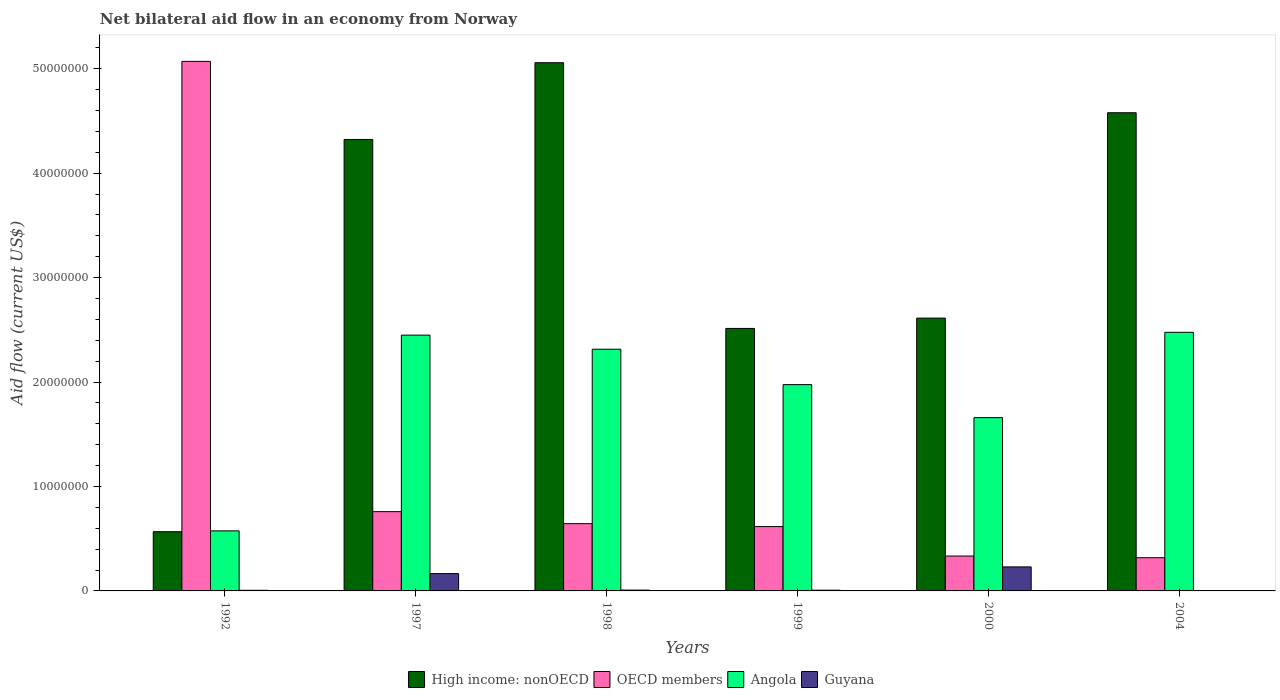Are the number of bars per tick equal to the number of legend labels?
Provide a succinct answer. Yes. Are the number of bars on each tick of the X-axis equal?
Offer a very short reply. Yes. How many bars are there on the 4th tick from the left?
Provide a short and direct response. 4. What is the label of the 5th group of bars from the left?
Offer a very short reply. 2000. In how many cases, is the number of bars for a given year not equal to the number of legend labels?
Your answer should be very brief. 0. What is the net bilateral aid flow in Angola in 1999?
Ensure brevity in your answer.  1.98e+07. Across all years, what is the maximum net bilateral aid flow in Guyana?
Ensure brevity in your answer.  2.30e+06. Across all years, what is the minimum net bilateral aid flow in Angola?
Provide a succinct answer. 5.75e+06. In which year was the net bilateral aid flow in OECD members maximum?
Your answer should be very brief. 1992. What is the total net bilateral aid flow in Angola in the graph?
Provide a short and direct response. 1.14e+08. What is the difference between the net bilateral aid flow in OECD members in 1992 and that in 2000?
Offer a very short reply. 4.74e+07. What is the difference between the net bilateral aid flow in Angola in 1998 and the net bilateral aid flow in Guyana in 1999?
Your response must be concise. 2.31e+07. What is the average net bilateral aid flow in OECD members per year?
Your answer should be very brief. 1.29e+07. In the year 1998, what is the difference between the net bilateral aid flow in Angola and net bilateral aid flow in Guyana?
Give a very brief answer. 2.31e+07. In how many years, is the net bilateral aid flow in Angola greater than 44000000 US$?
Your response must be concise. 0. What is the ratio of the net bilateral aid flow in Guyana in 1997 to that in 1999?
Offer a very short reply. 23.71. Is the difference between the net bilateral aid flow in Angola in 1992 and 2000 greater than the difference between the net bilateral aid flow in Guyana in 1992 and 2000?
Your answer should be compact. No. What is the difference between the highest and the second highest net bilateral aid flow in High income: nonOECD?
Provide a short and direct response. 4.79e+06. What is the difference between the highest and the lowest net bilateral aid flow in OECD members?
Give a very brief answer. 4.75e+07. Is the sum of the net bilateral aid flow in Angola in 1997 and 2000 greater than the maximum net bilateral aid flow in High income: nonOECD across all years?
Keep it short and to the point. No. Is it the case that in every year, the sum of the net bilateral aid flow in OECD members and net bilateral aid flow in Guyana is greater than the sum of net bilateral aid flow in High income: nonOECD and net bilateral aid flow in Angola?
Your answer should be compact. Yes. What does the 2nd bar from the right in 2004 represents?
Offer a terse response. Angola. Is it the case that in every year, the sum of the net bilateral aid flow in OECD members and net bilateral aid flow in Angola is greater than the net bilateral aid flow in High income: nonOECD?
Offer a terse response. No. Are all the bars in the graph horizontal?
Offer a terse response. No. How many years are there in the graph?
Keep it short and to the point. 6. What is the difference between two consecutive major ticks on the Y-axis?
Ensure brevity in your answer.  1.00e+07. Does the graph contain any zero values?
Keep it short and to the point. No. Does the graph contain grids?
Give a very brief answer. No. How many legend labels are there?
Provide a short and direct response. 4. What is the title of the graph?
Provide a short and direct response. Net bilateral aid flow in an economy from Norway. What is the label or title of the X-axis?
Give a very brief answer. Years. What is the label or title of the Y-axis?
Provide a succinct answer. Aid flow (current US$). What is the Aid flow (current US$) of High income: nonOECD in 1992?
Provide a short and direct response. 5.67e+06. What is the Aid flow (current US$) in OECD members in 1992?
Provide a short and direct response. 5.07e+07. What is the Aid flow (current US$) in Angola in 1992?
Ensure brevity in your answer.  5.75e+06. What is the Aid flow (current US$) in High income: nonOECD in 1997?
Your answer should be compact. 4.32e+07. What is the Aid flow (current US$) of OECD members in 1997?
Your answer should be compact. 7.59e+06. What is the Aid flow (current US$) in Angola in 1997?
Provide a succinct answer. 2.45e+07. What is the Aid flow (current US$) of Guyana in 1997?
Make the answer very short. 1.66e+06. What is the Aid flow (current US$) in High income: nonOECD in 1998?
Offer a very short reply. 5.06e+07. What is the Aid flow (current US$) in OECD members in 1998?
Keep it short and to the point. 6.44e+06. What is the Aid flow (current US$) of Angola in 1998?
Your answer should be compact. 2.31e+07. What is the Aid flow (current US$) in Guyana in 1998?
Your response must be concise. 8.00e+04. What is the Aid flow (current US$) in High income: nonOECD in 1999?
Your response must be concise. 2.51e+07. What is the Aid flow (current US$) in OECD members in 1999?
Offer a terse response. 6.16e+06. What is the Aid flow (current US$) in Angola in 1999?
Your answer should be compact. 1.98e+07. What is the Aid flow (current US$) in Guyana in 1999?
Make the answer very short. 7.00e+04. What is the Aid flow (current US$) of High income: nonOECD in 2000?
Your response must be concise. 2.61e+07. What is the Aid flow (current US$) of OECD members in 2000?
Ensure brevity in your answer.  3.34e+06. What is the Aid flow (current US$) in Angola in 2000?
Make the answer very short. 1.66e+07. What is the Aid flow (current US$) of Guyana in 2000?
Your answer should be very brief. 2.30e+06. What is the Aid flow (current US$) in High income: nonOECD in 2004?
Give a very brief answer. 4.58e+07. What is the Aid flow (current US$) of OECD members in 2004?
Make the answer very short. 3.18e+06. What is the Aid flow (current US$) in Angola in 2004?
Your answer should be compact. 2.48e+07. Across all years, what is the maximum Aid flow (current US$) of High income: nonOECD?
Give a very brief answer. 5.06e+07. Across all years, what is the maximum Aid flow (current US$) of OECD members?
Give a very brief answer. 5.07e+07. Across all years, what is the maximum Aid flow (current US$) in Angola?
Ensure brevity in your answer.  2.48e+07. Across all years, what is the maximum Aid flow (current US$) of Guyana?
Make the answer very short. 2.30e+06. Across all years, what is the minimum Aid flow (current US$) of High income: nonOECD?
Your response must be concise. 5.67e+06. Across all years, what is the minimum Aid flow (current US$) in OECD members?
Your response must be concise. 3.18e+06. Across all years, what is the minimum Aid flow (current US$) of Angola?
Give a very brief answer. 5.75e+06. Across all years, what is the minimum Aid flow (current US$) in Guyana?
Keep it short and to the point. 3.00e+04. What is the total Aid flow (current US$) in High income: nonOECD in the graph?
Your answer should be very brief. 1.96e+08. What is the total Aid flow (current US$) in OECD members in the graph?
Offer a very short reply. 7.74e+07. What is the total Aid flow (current US$) in Angola in the graph?
Offer a very short reply. 1.14e+08. What is the total Aid flow (current US$) of Guyana in the graph?
Provide a short and direct response. 4.20e+06. What is the difference between the Aid flow (current US$) in High income: nonOECD in 1992 and that in 1997?
Give a very brief answer. -3.76e+07. What is the difference between the Aid flow (current US$) in OECD members in 1992 and that in 1997?
Your answer should be compact. 4.31e+07. What is the difference between the Aid flow (current US$) in Angola in 1992 and that in 1997?
Your response must be concise. -1.87e+07. What is the difference between the Aid flow (current US$) in Guyana in 1992 and that in 1997?
Provide a short and direct response. -1.60e+06. What is the difference between the Aid flow (current US$) in High income: nonOECD in 1992 and that in 1998?
Offer a very short reply. -4.49e+07. What is the difference between the Aid flow (current US$) in OECD members in 1992 and that in 1998?
Offer a terse response. 4.43e+07. What is the difference between the Aid flow (current US$) in Angola in 1992 and that in 1998?
Provide a succinct answer. -1.74e+07. What is the difference between the Aid flow (current US$) in High income: nonOECD in 1992 and that in 1999?
Your response must be concise. -1.95e+07. What is the difference between the Aid flow (current US$) in OECD members in 1992 and that in 1999?
Your answer should be compact. 4.45e+07. What is the difference between the Aid flow (current US$) of Angola in 1992 and that in 1999?
Keep it short and to the point. -1.40e+07. What is the difference between the Aid flow (current US$) of Guyana in 1992 and that in 1999?
Your answer should be compact. -10000. What is the difference between the Aid flow (current US$) in High income: nonOECD in 1992 and that in 2000?
Keep it short and to the point. -2.04e+07. What is the difference between the Aid flow (current US$) of OECD members in 1992 and that in 2000?
Your answer should be very brief. 4.74e+07. What is the difference between the Aid flow (current US$) in Angola in 1992 and that in 2000?
Offer a terse response. -1.08e+07. What is the difference between the Aid flow (current US$) of Guyana in 1992 and that in 2000?
Provide a short and direct response. -2.24e+06. What is the difference between the Aid flow (current US$) of High income: nonOECD in 1992 and that in 2004?
Make the answer very short. -4.01e+07. What is the difference between the Aid flow (current US$) of OECD members in 1992 and that in 2004?
Give a very brief answer. 4.75e+07. What is the difference between the Aid flow (current US$) of Angola in 1992 and that in 2004?
Provide a short and direct response. -1.90e+07. What is the difference between the Aid flow (current US$) of Guyana in 1992 and that in 2004?
Your response must be concise. 3.00e+04. What is the difference between the Aid flow (current US$) in High income: nonOECD in 1997 and that in 1998?
Make the answer very short. -7.35e+06. What is the difference between the Aid flow (current US$) in OECD members in 1997 and that in 1998?
Give a very brief answer. 1.15e+06. What is the difference between the Aid flow (current US$) in Angola in 1997 and that in 1998?
Your answer should be compact. 1.35e+06. What is the difference between the Aid flow (current US$) in Guyana in 1997 and that in 1998?
Give a very brief answer. 1.58e+06. What is the difference between the Aid flow (current US$) in High income: nonOECD in 1997 and that in 1999?
Keep it short and to the point. 1.81e+07. What is the difference between the Aid flow (current US$) of OECD members in 1997 and that in 1999?
Your response must be concise. 1.43e+06. What is the difference between the Aid flow (current US$) of Angola in 1997 and that in 1999?
Give a very brief answer. 4.74e+06. What is the difference between the Aid flow (current US$) in Guyana in 1997 and that in 1999?
Your answer should be very brief. 1.59e+06. What is the difference between the Aid flow (current US$) in High income: nonOECD in 1997 and that in 2000?
Ensure brevity in your answer.  1.71e+07. What is the difference between the Aid flow (current US$) of OECD members in 1997 and that in 2000?
Provide a succinct answer. 4.25e+06. What is the difference between the Aid flow (current US$) of Angola in 1997 and that in 2000?
Keep it short and to the point. 7.90e+06. What is the difference between the Aid flow (current US$) in Guyana in 1997 and that in 2000?
Ensure brevity in your answer.  -6.40e+05. What is the difference between the Aid flow (current US$) in High income: nonOECD in 1997 and that in 2004?
Give a very brief answer. -2.56e+06. What is the difference between the Aid flow (current US$) in OECD members in 1997 and that in 2004?
Your response must be concise. 4.41e+06. What is the difference between the Aid flow (current US$) in Angola in 1997 and that in 2004?
Provide a succinct answer. -2.70e+05. What is the difference between the Aid flow (current US$) of Guyana in 1997 and that in 2004?
Your answer should be compact. 1.63e+06. What is the difference between the Aid flow (current US$) of High income: nonOECD in 1998 and that in 1999?
Give a very brief answer. 2.54e+07. What is the difference between the Aid flow (current US$) in OECD members in 1998 and that in 1999?
Offer a terse response. 2.80e+05. What is the difference between the Aid flow (current US$) in Angola in 1998 and that in 1999?
Provide a short and direct response. 3.39e+06. What is the difference between the Aid flow (current US$) in Guyana in 1998 and that in 1999?
Offer a very short reply. 10000. What is the difference between the Aid flow (current US$) in High income: nonOECD in 1998 and that in 2000?
Your answer should be compact. 2.44e+07. What is the difference between the Aid flow (current US$) in OECD members in 1998 and that in 2000?
Make the answer very short. 3.10e+06. What is the difference between the Aid flow (current US$) of Angola in 1998 and that in 2000?
Provide a short and direct response. 6.55e+06. What is the difference between the Aid flow (current US$) in Guyana in 1998 and that in 2000?
Offer a terse response. -2.22e+06. What is the difference between the Aid flow (current US$) in High income: nonOECD in 1998 and that in 2004?
Your answer should be very brief. 4.79e+06. What is the difference between the Aid flow (current US$) in OECD members in 1998 and that in 2004?
Provide a short and direct response. 3.26e+06. What is the difference between the Aid flow (current US$) of Angola in 1998 and that in 2004?
Give a very brief answer. -1.62e+06. What is the difference between the Aid flow (current US$) in Guyana in 1998 and that in 2004?
Offer a very short reply. 5.00e+04. What is the difference between the Aid flow (current US$) of High income: nonOECD in 1999 and that in 2000?
Your answer should be very brief. -9.90e+05. What is the difference between the Aid flow (current US$) in OECD members in 1999 and that in 2000?
Your answer should be compact. 2.82e+06. What is the difference between the Aid flow (current US$) of Angola in 1999 and that in 2000?
Your response must be concise. 3.16e+06. What is the difference between the Aid flow (current US$) in Guyana in 1999 and that in 2000?
Your answer should be compact. -2.23e+06. What is the difference between the Aid flow (current US$) in High income: nonOECD in 1999 and that in 2004?
Your answer should be compact. -2.06e+07. What is the difference between the Aid flow (current US$) of OECD members in 1999 and that in 2004?
Provide a succinct answer. 2.98e+06. What is the difference between the Aid flow (current US$) in Angola in 1999 and that in 2004?
Make the answer very short. -5.01e+06. What is the difference between the Aid flow (current US$) in Guyana in 1999 and that in 2004?
Offer a terse response. 4.00e+04. What is the difference between the Aid flow (current US$) in High income: nonOECD in 2000 and that in 2004?
Your answer should be very brief. -1.97e+07. What is the difference between the Aid flow (current US$) of Angola in 2000 and that in 2004?
Make the answer very short. -8.17e+06. What is the difference between the Aid flow (current US$) in Guyana in 2000 and that in 2004?
Keep it short and to the point. 2.27e+06. What is the difference between the Aid flow (current US$) in High income: nonOECD in 1992 and the Aid flow (current US$) in OECD members in 1997?
Offer a very short reply. -1.92e+06. What is the difference between the Aid flow (current US$) of High income: nonOECD in 1992 and the Aid flow (current US$) of Angola in 1997?
Keep it short and to the point. -1.88e+07. What is the difference between the Aid flow (current US$) in High income: nonOECD in 1992 and the Aid flow (current US$) in Guyana in 1997?
Make the answer very short. 4.01e+06. What is the difference between the Aid flow (current US$) in OECD members in 1992 and the Aid flow (current US$) in Angola in 1997?
Provide a short and direct response. 2.62e+07. What is the difference between the Aid flow (current US$) of OECD members in 1992 and the Aid flow (current US$) of Guyana in 1997?
Offer a very short reply. 4.90e+07. What is the difference between the Aid flow (current US$) of Angola in 1992 and the Aid flow (current US$) of Guyana in 1997?
Give a very brief answer. 4.09e+06. What is the difference between the Aid flow (current US$) of High income: nonOECD in 1992 and the Aid flow (current US$) of OECD members in 1998?
Offer a very short reply. -7.70e+05. What is the difference between the Aid flow (current US$) of High income: nonOECD in 1992 and the Aid flow (current US$) of Angola in 1998?
Your answer should be compact. -1.75e+07. What is the difference between the Aid flow (current US$) of High income: nonOECD in 1992 and the Aid flow (current US$) of Guyana in 1998?
Give a very brief answer. 5.59e+06. What is the difference between the Aid flow (current US$) of OECD members in 1992 and the Aid flow (current US$) of Angola in 1998?
Give a very brief answer. 2.76e+07. What is the difference between the Aid flow (current US$) in OECD members in 1992 and the Aid flow (current US$) in Guyana in 1998?
Your answer should be compact. 5.06e+07. What is the difference between the Aid flow (current US$) of Angola in 1992 and the Aid flow (current US$) of Guyana in 1998?
Provide a succinct answer. 5.67e+06. What is the difference between the Aid flow (current US$) of High income: nonOECD in 1992 and the Aid flow (current US$) of OECD members in 1999?
Provide a short and direct response. -4.90e+05. What is the difference between the Aid flow (current US$) of High income: nonOECD in 1992 and the Aid flow (current US$) of Angola in 1999?
Make the answer very short. -1.41e+07. What is the difference between the Aid flow (current US$) of High income: nonOECD in 1992 and the Aid flow (current US$) of Guyana in 1999?
Keep it short and to the point. 5.60e+06. What is the difference between the Aid flow (current US$) of OECD members in 1992 and the Aid flow (current US$) of Angola in 1999?
Offer a very short reply. 3.10e+07. What is the difference between the Aid flow (current US$) in OECD members in 1992 and the Aid flow (current US$) in Guyana in 1999?
Provide a succinct answer. 5.06e+07. What is the difference between the Aid flow (current US$) in Angola in 1992 and the Aid flow (current US$) in Guyana in 1999?
Give a very brief answer. 5.68e+06. What is the difference between the Aid flow (current US$) in High income: nonOECD in 1992 and the Aid flow (current US$) in OECD members in 2000?
Make the answer very short. 2.33e+06. What is the difference between the Aid flow (current US$) of High income: nonOECD in 1992 and the Aid flow (current US$) of Angola in 2000?
Give a very brief answer. -1.09e+07. What is the difference between the Aid flow (current US$) of High income: nonOECD in 1992 and the Aid flow (current US$) of Guyana in 2000?
Make the answer very short. 3.37e+06. What is the difference between the Aid flow (current US$) of OECD members in 1992 and the Aid flow (current US$) of Angola in 2000?
Offer a very short reply. 3.41e+07. What is the difference between the Aid flow (current US$) of OECD members in 1992 and the Aid flow (current US$) of Guyana in 2000?
Your response must be concise. 4.84e+07. What is the difference between the Aid flow (current US$) of Angola in 1992 and the Aid flow (current US$) of Guyana in 2000?
Give a very brief answer. 3.45e+06. What is the difference between the Aid flow (current US$) in High income: nonOECD in 1992 and the Aid flow (current US$) in OECD members in 2004?
Your answer should be compact. 2.49e+06. What is the difference between the Aid flow (current US$) of High income: nonOECD in 1992 and the Aid flow (current US$) of Angola in 2004?
Give a very brief answer. -1.91e+07. What is the difference between the Aid flow (current US$) in High income: nonOECD in 1992 and the Aid flow (current US$) in Guyana in 2004?
Provide a short and direct response. 5.64e+06. What is the difference between the Aid flow (current US$) of OECD members in 1992 and the Aid flow (current US$) of Angola in 2004?
Make the answer very short. 2.59e+07. What is the difference between the Aid flow (current US$) in OECD members in 1992 and the Aid flow (current US$) in Guyana in 2004?
Offer a terse response. 5.07e+07. What is the difference between the Aid flow (current US$) in Angola in 1992 and the Aid flow (current US$) in Guyana in 2004?
Offer a terse response. 5.72e+06. What is the difference between the Aid flow (current US$) of High income: nonOECD in 1997 and the Aid flow (current US$) of OECD members in 1998?
Your answer should be compact. 3.68e+07. What is the difference between the Aid flow (current US$) in High income: nonOECD in 1997 and the Aid flow (current US$) in Angola in 1998?
Your answer should be very brief. 2.01e+07. What is the difference between the Aid flow (current US$) in High income: nonOECD in 1997 and the Aid flow (current US$) in Guyana in 1998?
Your answer should be very brief. 4.31e+07. What is the difference between the Aid flow (current US$) of OECD members in 1997 and the Aid flow (current US$) of Angola in 1998?
Ensure brevity in your answer.  -1.56e+07. What is the difference between the Aid flow (current US$) in OECD members in 1997 and the Aid flow (current US$) in Guyana in 1998?
Offer a very short reply. 7.51e+06. What is the difference between the Aid flow (current US$) of Angola in 1997 and the Aid flow (current US$) of Guyana in 1998?
Keep it short and to the point. 2.44e+07. What is the difference between the Aid flow (current US$) in High income: nonOECD in 1997 and the Aid flow (current US$) in OECD members in 1999?
Keep it short and to the point. 3.71e+07. What is the difference between the Aid flow (current US$) of High income: nonOECD in 1997 and the Aid flow (current US$) of Angola in 1999?
Offer a very short reply. 2.35e+07. What is the difference between the Aid flow (current US$) of High income: nonOECD in 1997 and the Aid flow (current US$) of Guyana in 1999?
Offer a very short reply. 4.32e+07. What is the difference between the Aid flow (current US$) of OECD members in 1997 and the Aid flow (current US$) of Angola in 1999?
Keep it short and to the point. -1.22e+07. What is the difference between the Aid flow (current US$) in OECD members in 1997 and the Aid flow (current US$) in Guyana in 1999?
Your response must be concise. 7.52e+06. What is the difference between the Aid flow (current US$) of Angola in 1997 and the Aid flow (current US$) of Guyana in 1999?
Provide a short and direct response. 2.44e+07. What is the difference between the Aid flow (current US$) of High income: nonOECD in 1997 and the Aid flow (current US$) of OECD members in 2000?
Your response must be concise. 3.99e+07. What is the difference between the Aid flow (current US$) in High income: nonOECD in 1997 and the Aid flow (current US$) in Angola in 2000?
Make the answer very short. 2.66e+07. What is the difference between the Aid flow (current US$) of High income: nonOECD in 1997 and the Aid flow (current US$) of Guyana in 2000?
Ensure brevity in your answer.  4.09e+07. What is the difference between the Aid flow (current US$) of OECD members in 1997 and the Aid flow (current US$) of Angola in 2000?
Give a very brief answer. -9.00e+06. What is the difference between the Aid flow (current US$) in OECD members in 1997 and the Aid flow (current US$) in Guyana in 2000?
Provide a short and direct response. 5.29e+06. What is the difference between the Aid flow (current US$) of Angola in 1997 and the Aid flow (current US$) of Guyana in 2000?
Provide a succinct answer. 2.22e+07. What is the difference between the Aid flow (current US$) in High income: nonOECD in 1997 and the Aid flow (current US$) in OECD members in 2004?
Your answer should be very brief. 4.00e+07. What is the difference between the Aid flow (current US$) of High income: nonOECD in 1997 and the Aid flow (current US$) of Angola in 2004?
Ensure brevity in your answer.  1.85e+07. What is the difference between the Aid flow (current US$) of High income: nonOECD in 1997 and the Aid flow (current US$) of Guyana in 2004?
Provide a short and direct response. 4.32e+07. What is the difference between the Aid flow (current US$) of OECD members in 1997 and the Aid flow (current US$) of Angola in 2004?
Offer a terse response. -1.72e+07. What is the difference between the Aid flow (current US$) in OECD members in 1997 and the Aid flow (current US$) in Guyana in 2004?
Your response must be concise. 7.56e+06. What is the difference between the Aid flow (current US$) in Angola in 1997 and the Aid flow (current US$) in Guyana in 2004?
Your response must be concise. 2.45e+07. What is the difference between the Aid flow (current US$) of High income: nonOECD in 1998 and the Aid flow (current US$) of OECD members in 1999?
Offer a very short reply. 4.44e+07. What is the difference between the Aid flow (current US$) in High income: nonOECD in 1998 and the Aid flow (current US$) in Angola in 1999?
Your answer should be compact. 3.08e+07. What is the difference between the Aid flow (current US$) in High income: nonOECD in 1998 and the Aid flow (current US$) in Guyana in 1999?
Offer a terse response. 5.05e+07. What is the difference between the Aid flow (current US$) of OECD members in 1998 and the Aid flow (current US$) of Angola in 1999?
Ensure brevity in your answer.  -1.33e+07. What is the difference between the Aid flow (current US$) in OECD members in 1998 and the Aid flow (current US$) in Guyana in 1999?
Your answer should be very brief. 6.37e+06. What is the difference between the Aid flow (current US$) of Angola in 1998 and the Aid flow (current US$) of Guyana in 1999?
Provide a short and direct response. 2.31e+07. What is the difference between the Aid flow (current US$) of High income: nonOECD in 1998 and the Aid flow (current US$) of OECD members in 2000?
Offer a terse response. 4.72e+07. What is the difference between the Aid flow (current US$) in High income: nonOECD in 1998 and the Aid flow (current US$) in Angola in 2000?
Your answer should be very brief. 3.40e+07. What is the difference between the Aid flow (current US$) of High income: nonOECD in 1998 and the Aid flow (current US$) of Guyana in 2000?
Make the answer very short. 4.83e+07. What is the difference between the Aid flow (current US$) of OECD members in 1998 and the Aid flow (current US$) of Angola in 2000?
Your response must be concise. -1.02e+07. What is the difference between the Aid flow (current US$) of OECD members in 1998 and the Aid flow (current US$) of Guyana in 2000?
Your answer should be compact. 4.14e+06. What is the difference between the Aid flow (current US$) in Angola in 1998 and the Aid flow (current US$) in Guyana in 2000?
Your answer should be very brief. 2.08e+07. What is the difference between the Aid flow (current US$) in High income: nonOECD in 1998 and the Aid flow (current US$) in OECD members in 2004?
Make the answer very short. 4.74e+07. What is the difference between the Aid flow (current US$) of High income: nonOECD in 1998 and the Aid flow (current US$) of Angola in 2004?
Your response must be concise. 2.58e+07. What is the difference between the Aid flow (current US$) of High income: nonOECD in 1998 and the Aid flow (current US$) of Guyana in 2004?
Offer a very short reply. 5.05e+07. What is the difference between the Aid flow (current US$) of OECD members in 1998 and the Aid flow (current US$) of Angola in 2004?
Your answer should be compact. -1.83e+07. What is the difference between the Aid flow (current US$) of OECD members in 1998 and the Aid flow (current US$) of Guyana in 2004?
Your response must be concise. 6.41e+06. What is the difference between the Aid flow (current US$) in Angola in 1998 and the Aid flow (current US$) in Guyana in 2004?
Ensure brevity in your answer.  2.31e+07. What is the difference between the Aid flow (current US$) in High income: nonOECD in 1999 and the Aid flow (current US$) in OECD members in 2000?
Provide a short and direct response. 2.18e+07. What is the difference between the Aid flow (current US$) in High income: nonOECD in 1999 and the Aid flow (current US$) in Angola in 2000?
Offer a terse response. 8.54e+06. What is the difference between the Aid flow (current US$) of High income: nonOECD in 1999 and the Aid flow (current US$) of Guyana in 2000?
Offer a very short reply. 2.28e+07. What is the difference between the Aid flow (current US$) in OECD members in 1999 and the Aid flow (current US$) in Angola in 2000?
Provide a succinct answer. -1.04e+07. What is the difference between the Aid flow (current US$) in OECD members in 1999 and the Aid flow (current US$) in Guyana in 2000?
Offer a very short reply. 3.86e+06. What is the difference between the Aid flow (current US$) in Angola in 1999 and the Aid flow (current US$) in Guyana in 2000?
Your response must be concise. 1.74e+07. What is the difference between the Aid flow (current US$) in High income: nonOECD in 1999 and the Aid flow (current US$) in OECD members in 2004?
Keep it short and to the point. 2.20e+07. What is the difference between the Aid flow (current US$) of High income: nonOECD in 1999 and the Aid flow (current US$) of Guyana in 2004?
Give a very brief answer. 2.51e+07. What is the difference between the Aid flow (current US$) of OECD members in 1999 and the Aid flow (current US$) of Angola in 2004?
Keep it short and to the point. -1.86e+07. What is the difference between the Aid flow (current US$) in OECD members in 1999 and the Aid flow (current US$) in Guyana in 2004?
Keep it short and to the point. 6.13e+06. What is the difference between the Aid flow (current US$) of Angola in 1999 and the Aid flow (current US$) of Guyana in 2004?
Ensure brevity in your answer.  1.97e+07. What is the difference between the Aid flow (current US$) of High income: nonOECD in 2000 and the Aid flow (current US$) of OECD members in 2004?
Your answer should be compact. 2.29e+07. What is the difference between the Aid flow (current US$) in High income: nonOECD in 2000 and the Aid flow (current US$) in Angola in 2004?
Provide a succinct answer. 1.36e+06. What is the difference between the Aid flow (current US$) in High income: nonOECD in 2000 and the Aid flow (current US$) in Guyana in 2004?
Make the answer very short. 2.61e+07. What is the difference between the Aid flow (current US$) of OECD members in 2000 and the Aid flow (current US$) of Angola in 2004?
Ensure brevity in your answer.  -2.14e+07. What is the difference between the Aid flow (current US$) in OECD members in 2000 and the Aid flow (current US$) in Guyana in 2004?
Provide a succinct answer. 3.31e+06. What is the difference between the Aid flow (current US$) of Angola in 2000 and the Aid flow (current US$) of Guyana in 2004?
Provide a succinct answer. 1.66e+07. What is the average Aid flow (current US$) in High income: nonOECD per year?
Provide a short and direct response. 3.27e+07. What is the average Aid flow (current US$) in OECD members per year?
Your answer should be compact. 1.29e+07. What is the average Aid flow (current US$) in Angola per year?
Ensure brevity in your answer.  1.91e+07. What is the average Aid flow (current US$) of Guyana per year?
Give a very brief answer. 7.00e+05. In the year 1992, what is the difference between the Aid flow (current US$) in High income: nonOECD and Aid flow (current US$) in OECD members?
Give a very brief answer. -4.50e+07. In the year 1992, what is the difference between the Aid flow (current US$) of High income: nonOECD and Aid flow (current US$) of Angola?
Provide a succinct answer. -8.00e+04. In the year 1992, what is the difference between the Aid flow (current US$) in High income: nonOECD and Aid flow (current US$) in Guyana?
Make the answer very short. 5.61e+06. In the year 1992, what is the difference between the Aid flow (current US$) in OECD members and Aid flow (current US$) in Angola?
Provide a succinct answer. 4.50e+07. In the year 1992, what is the difference between the Aid flow (current US$) in OECD members and Aid flow (current US$) in Guyana?
Provide a succinct answer. 5.06e+07. In the year 1992, what is the difference between the Aid flow (current US$) in Angola and Aid flow (current US$) in Guyana?
Provide a succinct answer. 5.69e+06. In the year 1997, what is the difference between the Aid flow (current US$) of High income: nonOECD and Aid flow (current US$) of OECD members?
Offer a terse response. 3.56e+07. In the year 1997, what is the difference between the Aid flow (current US$) of High income: nonOECD and Aid flow (current US$) of Angola?
Offer a very short reply. 1.87e+07. In the year 1997, what is the difference between the Aid flow (current US$) in High income: nonOECD and Aid flow (current US$) in Guyana?
Make the answer very short. 4.16e+07. In the year 1997, what is the difference between the Aid flow (current US$) in OECD members and Aid flow (current US$) in Angola?
Your answer should be compact. -1.69e+07. In the year 1997, what is the difference between the Aid flow (current US$) in OECD members and Aid flow (current US$) in Guyana?
Your answer should be very brief. 5.93e+06. In the year 1997, what is the difference between the Aid flow (current US$) of Angola and Aid flow (current US$) of Guyana?
Ensure brevity in your answer.  2.28e+07. In the year 1998, what is the difference between the Aid flow (current US$) of High income: nonOECD and Aid flow (current US$) of OECD members?
Your response must be concise. 4.41e+07. In the year 1998, what is the difference between the Aid flow (current US$) in High income: nonOECD and Aid flow (current US$) in Angola?
Offer a terse response. 2.74e+07. In the year 1998, what is the difference between the Aid flow (current US$) of High income: nonOECD and Aid flow (current US$) of Guyana?
Your answer should be very brief. 5.05e+07. In the year 1998, what is the difference between the Aid flow (current US$) in OECD members and Aid flow (current US$) in Angola?
Make the answer very short. -1.67e+07. In the year 1998, what is the difference between the Aid flow (current US$) in OECD members and Aid flow (current US$) in Guyana?
Provide a short and direct response. 6.36e+06. In the year 1998, what is the difference between the Aid flow (current US$) of Angola and Aid flow (current US$) of Guyana?
Your response must be concise. 2.31e+07. In the year 1999, what is the difference between the Aid flow (current US$) of High income: nonOECD and Aid flow (current US$) of OECD members?
Offer a terse response. 1.90e+07. In the year 1999, what is the difference between the Aid flow (current US$) of High income: nonOECD and Aid flow (current US$) of Angola?
Your response must be concise. 5.38e+06. In the year 1999, what is the difference between the Aid flow (current US$) in High income: nonOECD and Aid flow (current US$) in Guyana?
Give a very brief answer. 2.51e+07. In the year 1999, what is the difference between the Aid flow (current US$) in OECD members and Aid flow (current US$) in Angola?
Provide a succinct answer. -1.36e+07. In the year 1999, what is the difference between the Aid flow (current US$) in OECD members and Aid flow (current US$) in Guyana?
Your answer should be very brief. 6.09e+06. In the year 1999, what is the difference between the Aid flow (current US$) of Angola and Aid flow (current US$) of Guyana?
Provide a succinct answer. 1.97e+07. In the year 2000, what is the difference between the Aid flow (current US$) of High income: nonOECD and Aid flow (current US$) of OECD members?
Give a very brief answer. 2.28e+07. In the year 2000, what is the difference between the Aid flow (current US$) of High income: nonOECD and Aid flow (current US$) of Angola?
Your answer should be compact. 9.53e+06. In the year 2000, what is the difference between the Aid flow (current US$) in High income: nonOECD and Aid flow (current US$) in Guyana?
Provide a succinct answer. 2.38e+07. In the year 2000, what is the difference between the Aid flow (current US$) of OECD members and Aid flow (current US$) of Angola?
Give a very brief answer. -1.32e+07. In the year 2000, what is the difference between the Aid flow (current US$) in OECD members and Aid flow (current US$) in Guyana?
Your answer should be compact. 1.04e+06. In the year 2000, what is the difference between the Aid flow (current US$) of Angola and Aid flow (current US$) of Guyana?
Your response must be concise. 1.43e+07. In the year 2004, what is the difference between the Aid flow (current US$) in High income: nonOECD and Aid flow (current US$) in OECD members?
Make the answer very short. 4.26e+07. In the year 2004, what is the difference between the Aid flow (current US$) in High income: nonOECD and Aid flow (current US$) in Angola?
Make the answer very short. 2.10e+07. In the year 2004, what is the difference between the Aid flow (current US$) in High income: nonOECD and Aid flow (current US$) in Guyana?
Your response must be concise. 4.58e+07. In the year 2004, what is the difference between the Aid flow (current US$) of OECD members and Aid flow (current US$) of Angola?
Your answer should be very brief. -2.16e+07. In the year 2004, what is the difference between the Aid flow (current US$) of OECD members and Aid flow (current US$) of Guyana?
Offer a terse response. 3.15e+06. In the year 2004, what is the difference between the Aid flow (current US$) of Angola and Aid flow (current US$) of Guyana?
Provide a short and direct response. 2.47e+07. What is the ratio of the Aid flow (current US$) in High income: nonOECD in 1992 to that in 1997?
Make the answer very short. 0.13. What is the ratio of the Aid flow (current US$) of OECD members in 1992 to that in 1997?
Your answer should be very brief. 6.68. What is the ratio of the Aid flow (current US$) in Angola in 1992 to that in 1997?
Make the answer very short. 0.23. What is the ratio of the Aid flow (current US$) in Guyana in 1992 to that in 1997?
Offer a terse response. 0.04. What is the ratio of the Aid flow (current US$) of High income: nonOECD in 1992 to that in 1998?
Offer a very short reply. 0.11. What is the ratio of the Aid flow (current US$) of OECD members in 1992 to that in 1998?
Provide a short and direct response. 7.87. What is the ratio of the Aid flow (current US$) of Angola in 1992 to that in 1998?
Keep it short and to the point. 0.25. What is the ratio of the Aid flow (current US$) of Guyana in 1992 to that in 1998?
Keep it short and to the point. 0.75. What is the ratio of the Aid flow (current US$) of High income: nonOECD in 1992 to that in 1999?
Your answer should be compact. 0.23. What is the ratio of the Aid flow (current US$) in OECD members in 1992 to that in 1999?
Keep it short and to the point. 8.23. What is the ratio of the Aid flow (current US$) in Angola in 1992 to that in 1999?
Give a very brief answer. 0.29. What is the ratio of the Aid flow (current US$) of Guyana in 1992 to that in 1999?
Ensure brevity in your answer.  0.86. What is the ratio of the Aid flow (current US$) in High income: nonOECD in 1992 to that in 2000?
Offer a terse response. 0.22. What is the ratio of the Aid flow (current US$) of OECD members in 1992 to that in 2000?
Provide a succinct answer. 15.18. What is the ratio of the Aid flow (current US$) in Angola in 1992 to that in 2000?
Provide a short and direct response. 0.35. What is the ratio of the Aid flow (current US$) of Guyana in 1992 to that in 2000?
Provide a short and direct response. 0.03. What is the ratio of the Aid flow (current US$) in High income: nonOECD in 1992 to that in 2004?
Make the answer very short. 0.12. What is the ratio of the Aid flow (current US$) of OECD members in 1992 to that in 2004?
Ensure brevity in your answer.  15.94. What is the ratio of the Aid flow (current US$) of Angola in 1992 to that in 2004?
Keep it short and to the point. 0.23. What is the ratio of the Aid flow (current US$) in High income: nonOECD in 1997 to that in 1998?
Your answer should be very brief. 0.85. What is the ratio of the Aid flow (current US$) of OECD members in 1997 to that in 1998?
Your answer should be compact. 1.18. What is the ratio of the Aid flow (current US$) of Angola in 1997 to that in 1998?
Offer a terse response. 1.06. What is the ratio of the Aid flow (current US$) of Guyana in 1997 to that in 1998?
Your response must be concise. 20.75. What is the ratio of the Aid flow (current US$) of High income: nonOECD in 1997 to that in 1999?
Give a very brief answer. 1.72. What is the ratio of the Aid flow (current US$) in OECD members in 1997 to that in 1999?
Keep it short and to the point. 1.23. What is the ratio of the Aid flow (current US$) in Angola in 1997 to that in 1999?
Offer a terse response. 1.24. What is the ratio of the Aid flow (current US$) of Guyana in 1997 to that in 1999?
Offer a very short reply. 23.71. What is the ratio of the Aid flow (current US$) in High income: nonOECD in 1997 to that in 2000?
Keep it short and to the point. 1.65. What is the ratio of the Aid flow (current US$) in OECD members in 1997 to that in 2000?
Provide a short and direct response. 2.27. What is the ratio of the Aid flow (current US$) in Angola in 1997 to that in 2000?
Offer a very short reply. 1.48. What is the ratio of the Aid flow (current US$) in Guyana in 1997 to that in 2000?
Give a very brief answer. 0.72. What is the ratio of the Aid flow (current US$) in High income: nonOECD in 1997 to that in 2004?
Offer a very short reply. 0.94. What is the ratio of the Aid flow (current US$) in OECD members in 1997 to that in 2004?
Offer a very short reply. 2.39. What is the ratio of the Aid flow (current US$) in Guyana in 1997 to that in 2004?
Provide a succinct answer. 55.33. What is the ratio of the Aid flow (current US$) in High income: nonOECD in 1998 to that in 1999?
Your answer should be compact. 2.01. What is the ratio of the Aid flow (current US$) in OECD members in 1998 to that in 1999?
Give a very brief answer. 1.05. What is the ratio of the Aid flow (current US$) of Angola in 1998 to that in 1999?
Provide a succinct answer. 1.17. What is the ratio of the Aid flow (current US$) in High income: nonOECD in 1998 to that in 2000?
Your answer should be very brief. 1.94. What is the ratio of the Aid flow (current US$) of OECD members in 1998 to that in 2000?
Keep it short and to the point. 1.93. What is the ratio of the Aid flow (current US$) in Angola in 1998 to that in 2000?
Provide a succinct answer. 1.39. What is the ratio of the Aid flow (current US$) of Guyana in 1998 to that in 2000?
Offer a very short reply. 0.03. What is the ratio of the Aid flow (current US$) in High income: nonOECD in 1998 to that in 2004?
Offer a very short reply. 1.1. What is the ratio of the Aid flow (current US$) of OECD members in 1998 to that in 2004?
Give a very brief answer. 2.03. What is the ratio of the Aid flow (current US$) in Angola in 1998 to that in 2004?
Your response must be concise. 0.93. What is the ratio of the Aid flow (current US$) in Guyana in 1998 to that in 2004?
Your answer should be very brief. 2.67. What is the ratio of the Aid flow (current US$) in High income: nonOECD in 1999 to that in 2000?
Your answer should be very brief. 0.96. What is the ratio of the Aid flow (current US$) of OECD members in 1999 to that in 2000?
Give a very brief answer. 1.84. What is the ratio of the Aid flow (current US$) of Angola in 1999 to that in 2000?
Your response must be concise. 1.19. What is the ratio of the Aid flow (current US$) of Guyana in 1999 to that in 2000?
Provide a succinct answer. 0.03. What is the ratio of the Aid flow (current US$) of High income: nonOECD in 1999 to that in 2004?
Your answer should be compact. 0.55. What is the ratio of the Aid flow (current US$) in OECD members in 1999 to that in 2004?
Ensure brevity in your answer.  1.94. What is the ratio of the Aid flow (current US$) of Angola in 1999 to that in 2004?
Keep it short and to the point. 0.8. What is the ratio of the Aid flow (current US$) of Guyana in 1999 to that in 2004?
Make the answer very short. 2.33. What is the ratio of the Aid flow (current US$) of High income: nonOECD in 2000 to that in 2004?
Ensure brevity in your answer.  0.57. What is the ratio of the Aid flow (current US$) of OECD members in 2000 to that in 2004?
Offer a very short reply. 1.05. What is the ratio of the Aid flow (current US$) of Angola in 2000 to that in 2004?
Give a very brief answer. 0.67. What is the ratio of the Aid flow (current US$) in Guyana in 2000 to that in 2004?
Your answer should be compact. 76.67. What is the difference between the highest and the second highest Aid flow (current US$) of High income: nonOECD?
Make the answer very short. 4.79e+06. What is the difference between the highest and the second highest Aid flow (current US$) of OECD members?
Ensure brevity in your answer.  4.31e+07. What is the difference between the highest and the second highest Aid flow (current US$) of Angola?
Offer a very short reply. 2.70e+05. What is the difference between the highest and the second highest Aid flow (current US$) of Guyana?
Make the answer very short. 6.40e+05. What is the difference between the highest and the lowest Aid flow (current US$) of High income: nonOECD?
Your answer should be compact. 4.49e+07. What is the difference between the highest and the lowest Aid flow (current US$) of OECD members?
Your answer should be very brief. 4.75e+07. What is the difference between the highest and the lowest Aid flow (current US$) in Angola?
Your answer should be compact. 1.90e+07. What is the difference between the highest and the lowest Aid flow (current US$) in Guyana?
Give a very brief answer. 2.27e+06. 